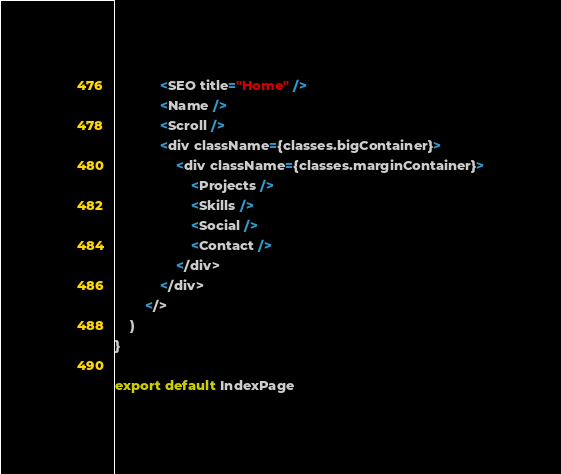<code> <loc_0><loc_0><loc_500><loc_500><_JavaScript_>            <SEO title="Home" />
            <Name />
            <Scroll />
            <div className={classes.bigContainer}>
                <div className={classes.marginContainer}>
                    <Projects />
                    <Skills />
                    <Social />
                    <Contact />
                </div>
            </div>
        </>
    )
}

export default IndexPage
</code> 